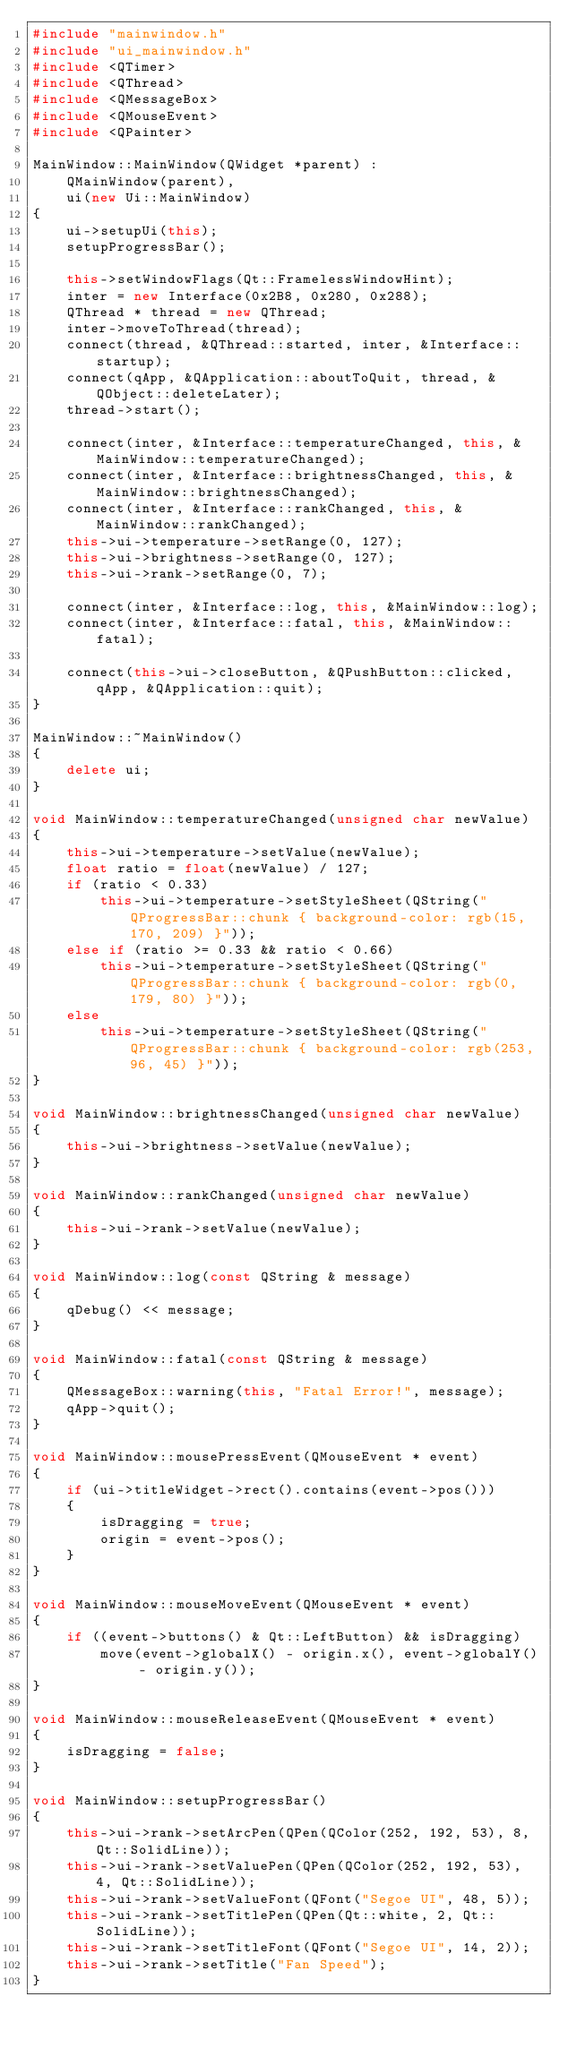Convert code to text. <code><loc_0><loc_0><loc_500><loc_500><_C++_>#include "mainwindow.h"
#include "ui_mainwindow.h"
#include <QTimer>
#include <QThread>
#include <QMessageBox>
#include <QMouseEvent>
#include <QPainter>

MainWindow::MainWindow(QWidget *parent) :
    QMainWindow(parent),
    ui(new Ui::MainWindow)
{
    ui->setupUi(this);
    setupProgressBar();

    this->setWindowFlags(Qt::FramelessWindowHint);
    inter = new Interface(0x2B8, 0x280, 0x288);
    QThread * thread = new QThread;
    inter->moveToThread(thread);
    connect(thread, &QThread::started, inter, &Interface::startup);
    connect(qApp, &QApplication::aboutToQuit, thread, &QObject::deleteLater);
    thread->start();
    
    connect(inter, &Interface::temperatureChanged, this, &MainWindow::temperatureChanged);
    connect(inter, &Interface::brightnessChanged, this, &MainWindow::brightnessChanged);
    connect(inter, &Interface::rankChanged, this, &MainWindow::rankChanged);
    this->ui->temperature->setRange(0, 127);
    this->ui->brightness->setRange(0, 127);
    this->ui->rank->setRange(0, 7);

    connect(inter, &Interface::log, this, &MainWindow::log);
    connect(inter, &Interface::fatal, this, &MainWindow::fatal);
    
    connect(this->ui->closeButton, &QPushButton::clicked, qApp, &QApplication::quit);
}

MainWindow::~MainWindow()
{
    delete ui;
}

void MainWindow::temperatureChanged(unsigned char newValue)
{
    this->ui->temperature->setValue(newValue);
    float ratio = float(newValue) / 127;
    if (ratio < 0.33)
        this->ui->temperature->setStyleSheet(QString("QProgressBar::chunk { background-color: rgb(15, 170, 209) }"));
    else if (ratio >= 0.33 && ratio < 0.66)
        this->ui->temperature->setStyleSheet(QString("QProgressBar::chunk { background-color: rgb(0, 179, 80) }"));
    else
        this->ui->temperature->setStyleSheet(QString("QProgressBar::chunk { background-color: rgb(253, 96, 45) }"));
}

void MainWindow::brightnessChanged(unsigned char newValue)
{
    this->ui->brightness->setValue(newValue);
}

void MainWindow::rankChanged(unsigned char newValue)
{
    this->ui->rank->setValue(newValue);
}

void MainWindow::log(const QString & message)
{
    qDebug() << message;
}

void MainWindow::fatal(const QString & message)
{
    QMessageBox::warning(this, "Fatal Error!", message);
    qApp->quit();
}

void MainWindow::mousePressEvent(QMouseEvent * event)
{
    if (ui->titleWidget->rect().contains(event->pos()))
    {
        isDragging = true;
        origin = event->pos();
    }
}

void MainWindow::mouseMoveEvent(QMouseEvent * event)
{
    if ((event->buttons() & Qt::LeftButton) && isDragging)
        move(event->globalX() - origin.x(), event->globalY() - origin.y());
}

void MainWindow::mouseReleaseEvent(QMouseEvent * event)
{
    isDragging = false;
}

void MainWindow::setupProgressBar()
{
    this->ui->rank->setArcPen(QPen(QColor(252, 192, 53), 8, Qt::SolidLine));
    this->ui->rank->setValuePen(QPen(QColor(252, 192, 53), 4, Qt::SolidLine));
    this->ui->rank->setValueFont(QFont("Segoe UI", 48, 5));
    this->ui->rank->setTitlePen(QPen(Qt::white, 2, Qt::SolidLine));
    this->ui->rank->setTitleFont(QFont("Segoe UI", 14, 2));
    this->ui->rank->setTitle("Fan Speed");
}
</code> 